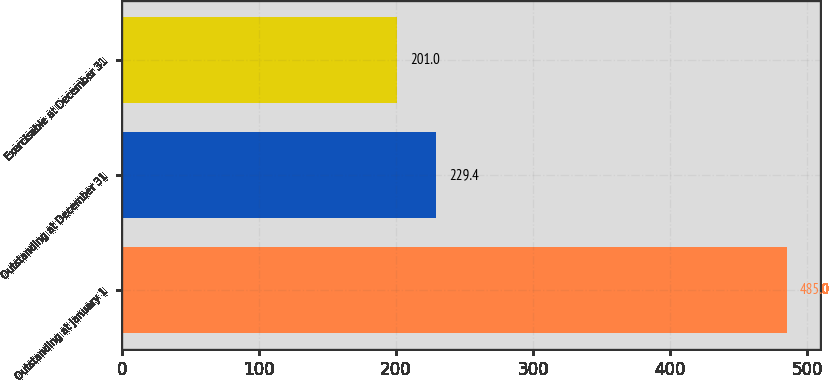Convert chart to OTSL. <chart><loc_0><loc_0><loc_500><loc_500><bar_chart><fcel>Outstanding at January 1<fcel>Outstanding at December 31<fcel>Exercisable at December 31<nl><fcel>485<fcel>229.4<fcel>201<nl></chart> 